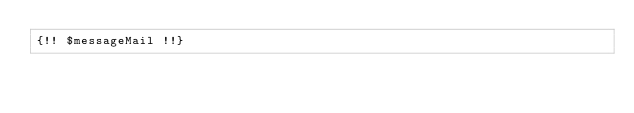<code> <loc_0><loc_0><loc_500><loc_500><_PHP_>{!! $messageMail !!}</code> 